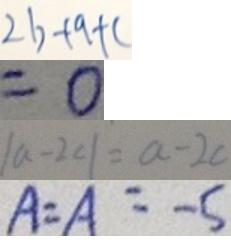<formula> <loc_0><loc_0><loc_500><loc_500>2 b + 9 + c 
 = 0 
 \vert a - 2 c \vert = a - 2 c 
 A = A = - 5</formula> 